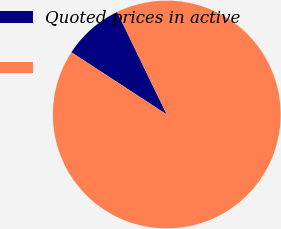Convert chart to OTSL. <chart><loc_0><loc_0><loc_500><loc_500><pie_chart><fcel>Quoted prices in active<fcel>Unnamed: 1<nl><fcel>8.62%<fcel>91.38%<nl></chart> 